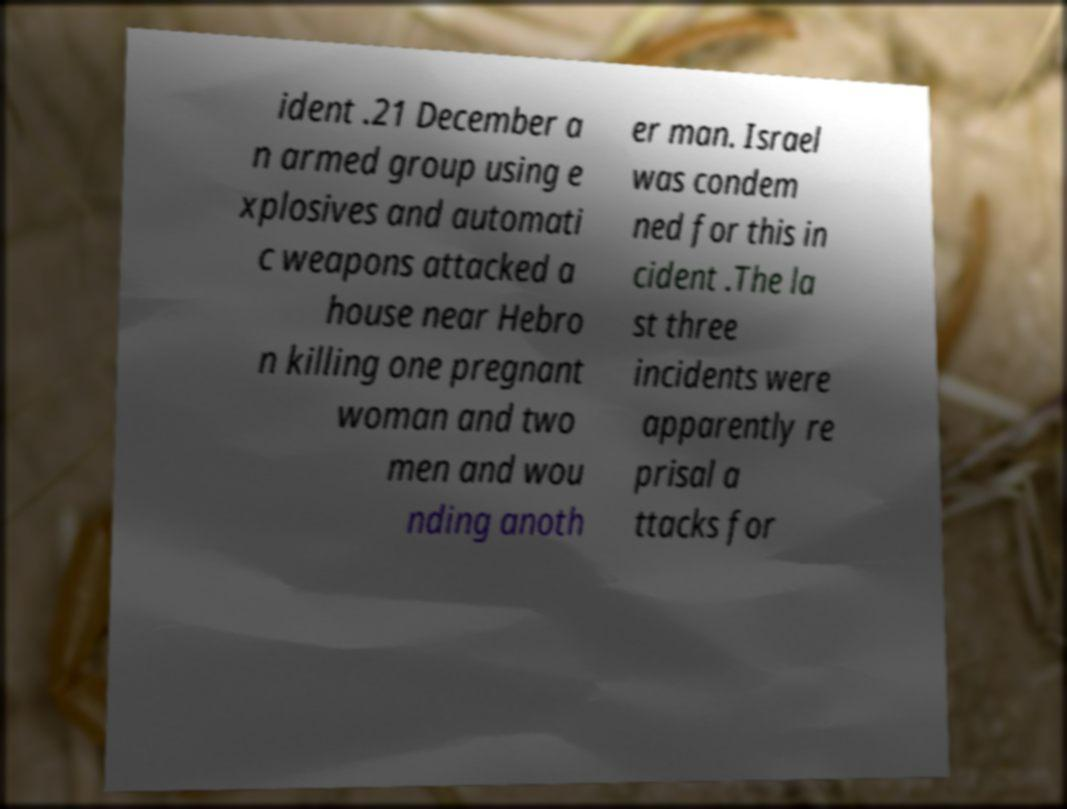Please read and relay the text visible in this image. What does it say? ident .21 December a n armed group using e xplosives and automati c weapons attacked a house near Hebro n killing one pregnant woman and two men and wou nding anoth er man. Israel was condem ned for this in cident .The la st three incidents were apparently re prisal a ttacks for 